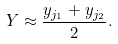<formula> <loc_0><loc_0><loc_500><loc_500>Y \approx \frac { y _ { j _ { 1 } } + y _ { j _ { 2 } } } { 2 } .</formula> 